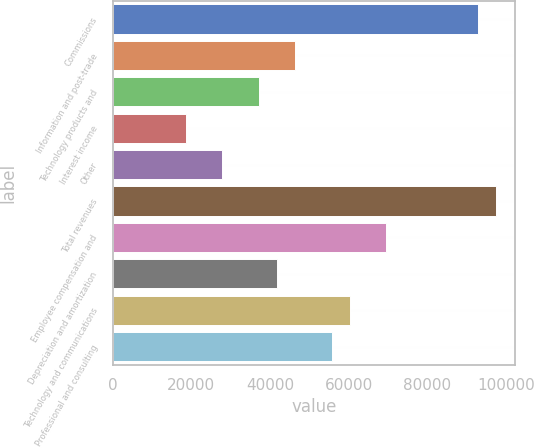Convert chart to OTSL. <chart><loc_0><loc_0><loc_500><loc_500><bar_chart><fcel>Commissions<fcel>Information and post-trade<fcel>Technology products and<fcel>Interest income<fcel>Other<fcel>Total revenues<fcel>Employee compensation and<fcel>Depreciation and amortization<fcel>Technology and communications<fcel>Professional and consulting<nl><fcel>92806<fcel>46403<fcel>37122.4<fcel>18561.2<fcel>27841.8<fcel>97446.3<fcel>69604.5<fcel>41762.7<fcel>60323.9<fcel>55683.6<nl></chart> 